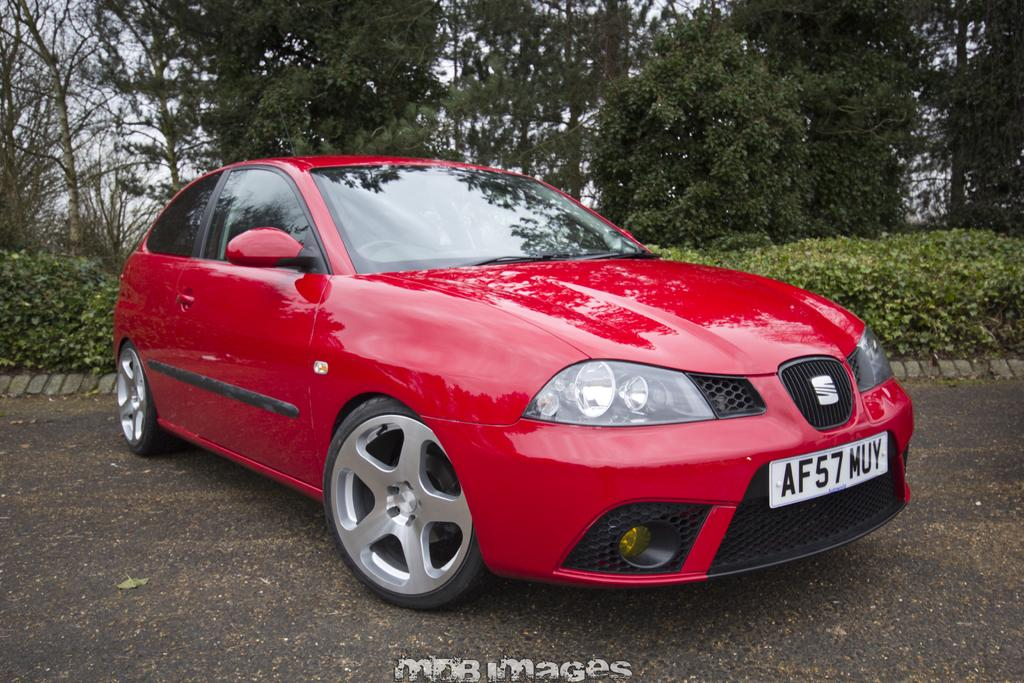What is the main subject of the image? There is a vehicle on the road in the image. What can be seen in the background of the image? There are plants and many trees visible in the background of the image. What part of the natural environment is visible in the image? The sky is visible in the background of the image. What type of wire is holding up the vehicle in the image? There is no wire holding up the vehicle in the image; it is on the road. What mark can be seen on the vehicle in the image? There is no specific mark mentioned in the provided facts, so we cannot determine if there is a mark on the vehicle. 